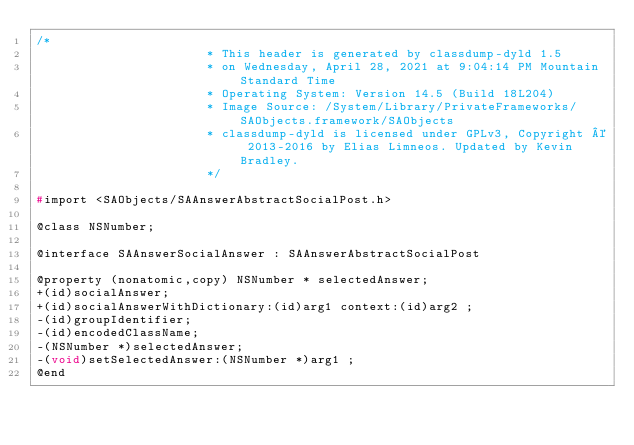Convert code to text. <code><loc_0><loc_0><loc_500><loc_500><_C_>/*
                       * This header is generated by classdump-dyld 1.5
                       * on Wednesday, April 28, 2021 at 9:04:14 PM Mountain Standard Time
                       * Operating System: Version 14.5 (Build 18L204)
                       * Image Source: /System/Library/PrivateFrameworks/SAObjects.framework/SAObjects
                       * classdump-dyld is licensed under GPLv3, Copyright © 2013-2016 by Elias Limneos. Updated by Kevin Bradley.
                       */

#import <SAObjects/SAAnswerAbstractSocialPost.h>

@class NSNumber;

@interface SAAnswerSocialAnswer : SAAnswerAbstractSocialPost

@property (nonatomic,copy) NSNumber * selectedAnswer; 
+(id)socialAnswer;
+(id)socialAnswerWithDictionary:(id)arg1 context:(id)arg2 ;
-(id)groupIdentifier;
-(id)encodedClassName;
-(NSNumber *)selectedAnswer;
-(void)setSelectedAnswer:(NSNumber *)arg1 ;
@end

</code> 